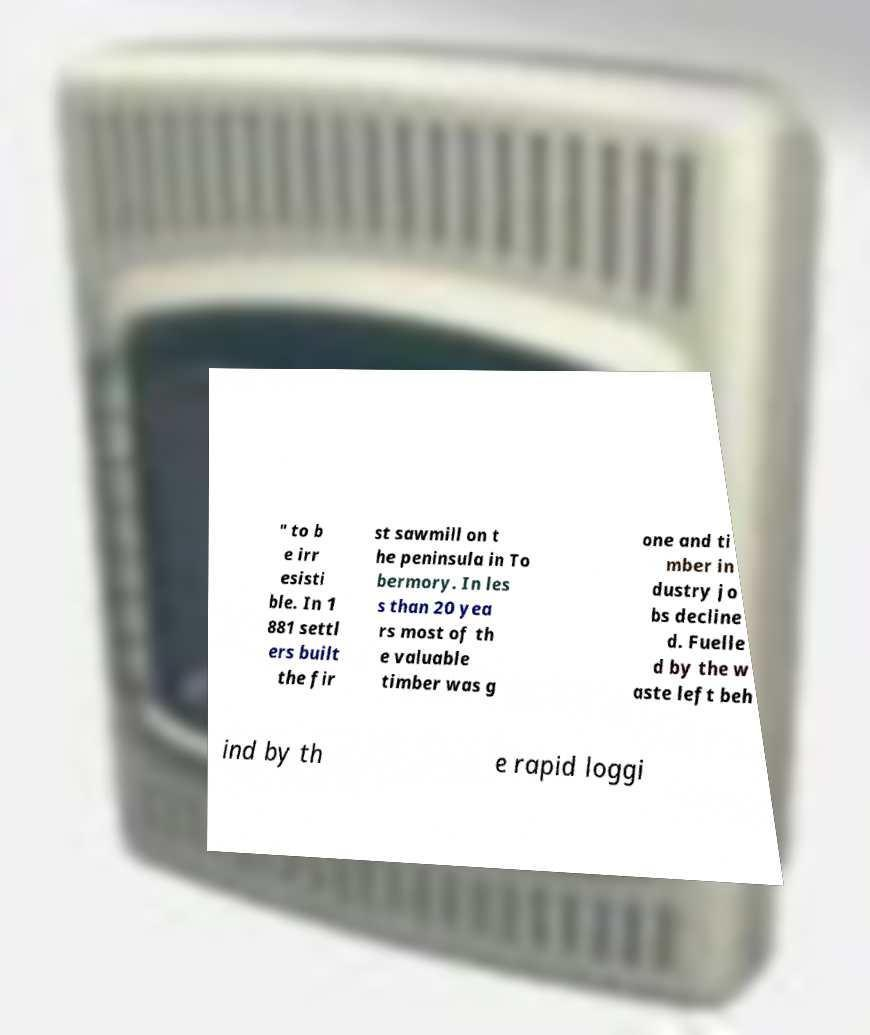Can you accurately transcribe the text from the provided image for me? " to b e irr esisti ble. In 1 881 settl ers built the fir st sawmill on t he peninsula in To bermory. In les s than 20 yea rs most of th e valuable timber was g one and ti mber in dustry jo bs decline d. Fuelle d by the w aste left beh ind by th e rapid loggi 